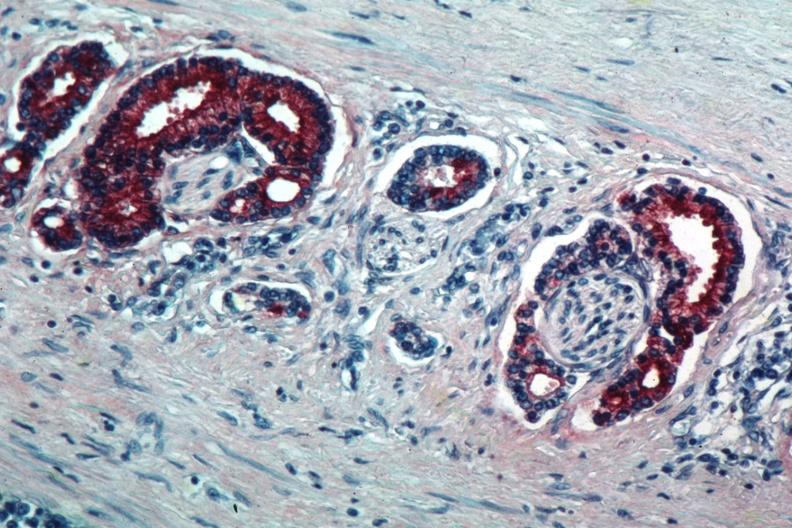what shows marked staining in perineural neoplasm?
Answer the question using a single word or phrase. Med immunostain for prostate specific antigen 